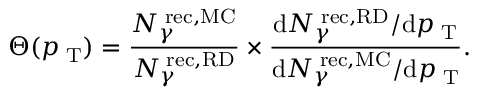Convert formula to latex. <formula><loc_0><loc_0><loc_500><loc_500>\Theta ( p _ { T } ) = \frac { N _ { \gamma } ^ { r e c , M C } } { N _ { \gamma } ^ { r e c , R D } } \times \frac { d N _ { \gamma } ^ { r e c , R D } / d p _ { T } } { d N _ { \gamma } ^ { r e c , M C } / d p _ { T } } .</formula> 